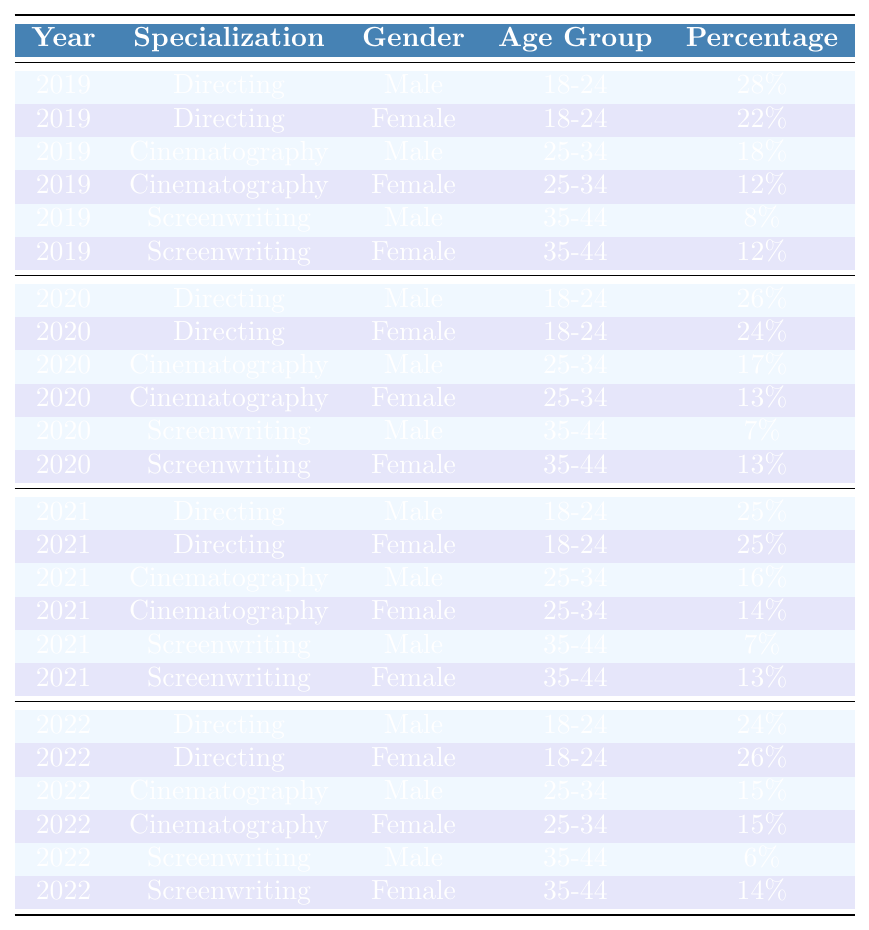What was the percentage of female graduates specializing in Directing in 2021? In the table, under the year 2021, for the specialization "Directing," we see two entries: one for males (25%) and one for females (25%). Therefore, the percentage of female graduates in Directing in 2021 is 25%.
Answer: 25% Which specialization had the highest percentage of male graduates in 2019? By examining the entries for males in 2019, we see that "Directing" has 28%, "Cinematography" has 18%, and "Screenwriting" has 8%. The highest percentage among these is from Directing, which is 28%.
Answer: 28% What is the difference in percentage of male graduates in Screenwriting between 2019 and 2022? For Screenwriting, the percentage of male graduates in 2019 is 8%, and in 2022 it is 6%. To find the difference, we subtract 6% from 8%, resulting in a difference of 2%.
Answer: 2% Was there an increase in the percentage of female graduates in Cinematography from 2019 to 2022? For Cinematography, the percentage of female graduates in 2019 is 12%, and in 2022 it is 15%. Since 15% is greater than 12%, we can conclude that there was indeed an increase.
Answer: Yes What was the average percentage of male graduates in Directing over the years from 2019 to 2022? The percentages of male graduates in Directing from 2019 to 2022 are: 28%, 26%, 25%, and 24%. To find the average, we sum these percentages: 28 + 26 + 25 + 24 = 103, and then divide by 4 (the number of years), giving us an average of 25.75%.
Answer: 25.75% In 2020, did the percentage of female graduates in Screenwriting increase, decrease, or stay the same compared to 2019? The percentage of female graduates in Screenwriting in 2019 is 12% and in 2020 it is 13%. Since 13% is higher than 12%, this indicates an increase.
Answer: Increase What year had the highest percentage of female graduates in Directing? The percentages of female graduates in Directing over the years are: 22% in 2019, 24% in 2020, 25% in 2021, and 26% in 2022. The highest percentage is 26% in 2022.
Answer: 26% Count of male graduates in Cinematography for 2021 and 2022 combined? The percentages of male graduates in Cinematography are 16% in 2021 and 15% in 2022. Adding them together gives us 16 + 15 = 31%. Therefore, the count of male graduates in Cinematography for 2021 and 2022 is 31%.
Answer: 31% How does the age group of 35-44 males in Screenwriting compare between 2019 and 2021? The percentages for males in Screenwriting for the age group 35-44 are 8% in 2019 and 7% in 2021. To compare, 7% is lower than 8%, indicating a decrease over the years.
Answer: Decrease 